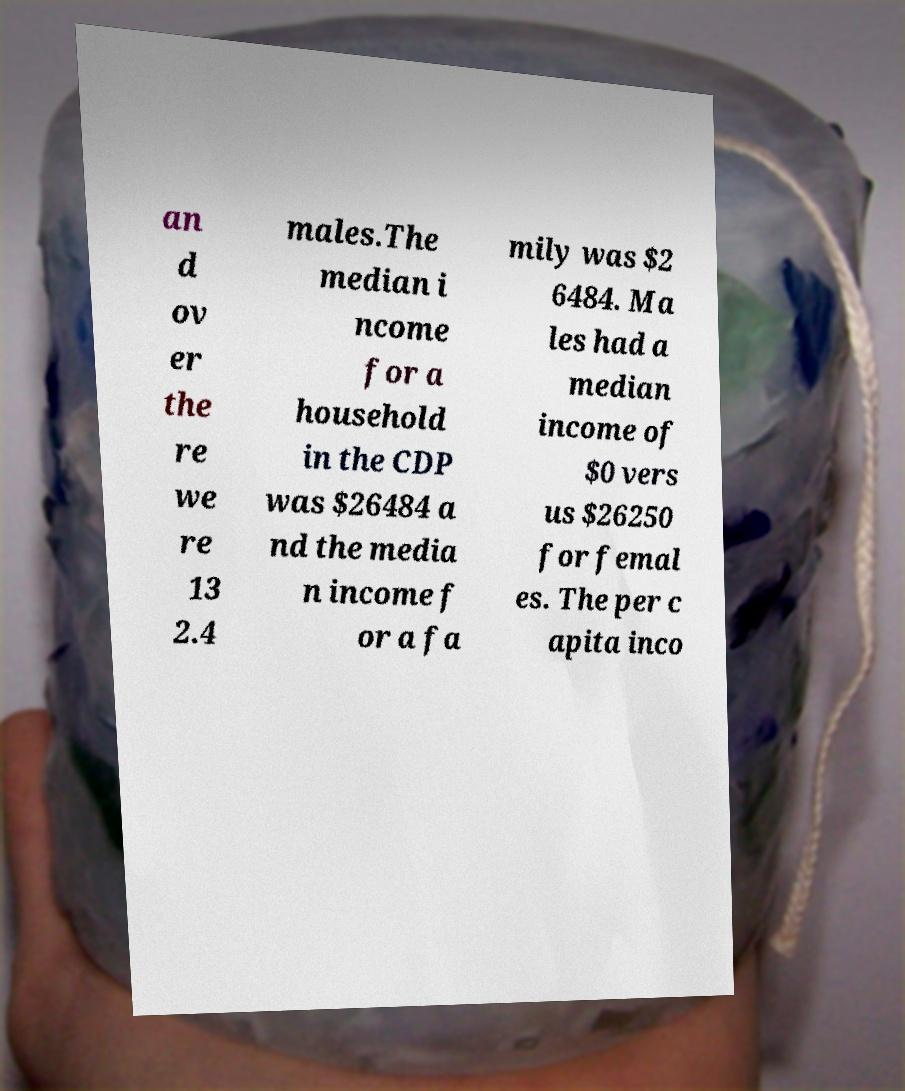Could you extract and type out the text from this image? an d ov er the re we re 13 2.4 males.The median i ncome for a household in the CDP was $26484 a nd the media n income f or a fa mily was $2 6484. Ma les had a median income of $0 vers us $26250 for femal es. The per c apita inco 